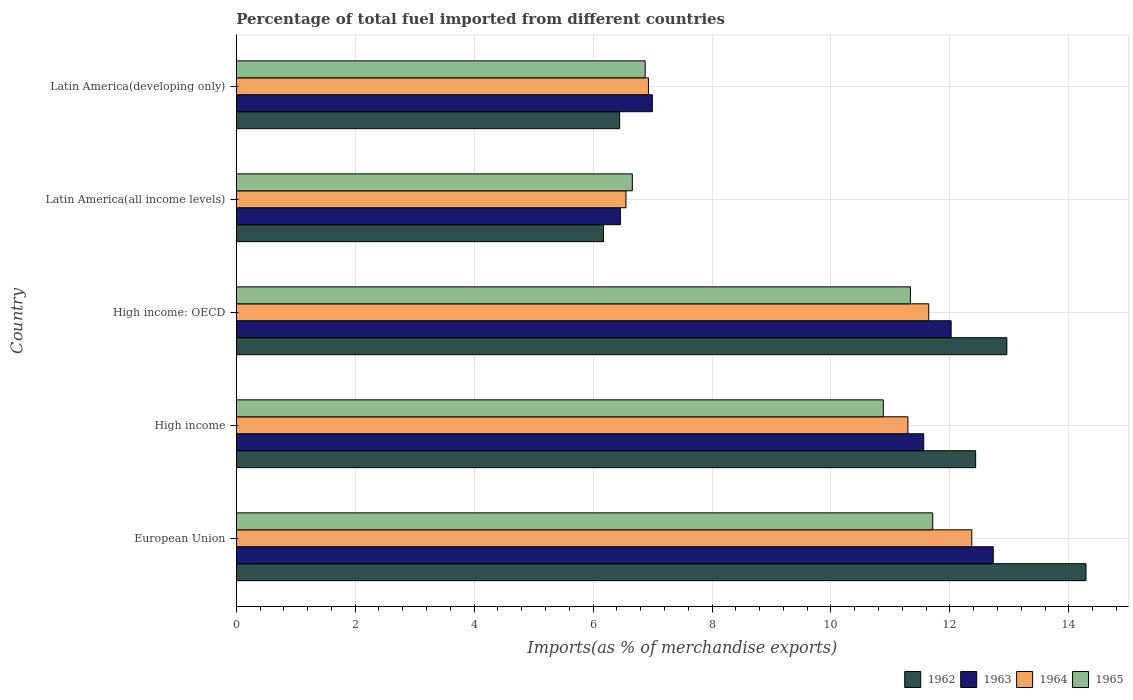How many different coloured bars are there?
Offer a terse response. 4. Are the number of bars on each tick of the Y-axis equal?
Offer a very short reply. Yes. What is the label of the 2nd group of bars from the top?
Give a very brief answer. Latin America(all income levels). What is the percentage of imports to different countries in 1962 in Latin America(developing only)?
Provide a succinct answer. 6.45. Across all countries, what is the maximum percentage of imports to different countries in 1964?
Your answer should be very brief. 12.37. Across all countries, what is the minimum percentage of imports to different countries in 1964?
Your response must be concise. 6.55. In which country was the percentage of imports to different countries in 1965 minimum?
Give a very brief answer. Latin America(all income levels). What is the total percentage of imports to different countries in 1963 in the graph?
Make the answer very short. 49.76. What is the difference between the percentage of imports to different countries in 1964 in European Union and that in Latin America(developing only)?
Provide a succinct answer. 5.44. What is the difference between the percentage of imports to different countries in 1965 in High income and the percentage of imports to different countries in 1963 in European Union?
Offer a very short reply. -1.85. What is the average percentage of imports to different countries in 1964 per country?
Give a very brief answer. 9.76. What is the difference between the percentage of imports to different countries in 1963 and percentage of imports to different countries in 1962 in European Union?
Your response must be concise. -1.56. What is the ratio of the percentage of imports to different countries in 1965 in European Union to that in High income?
Give a very brief answer. 1.08. Is the percentage of imports to different countries in 1962 in High income less than that in High income: OECD?
Provide a short and direct response. Yes. What is the difference between the highest and the second highest percentage of imports to different countries in 1964?
Offer a terse response. 0.72. What is the difference between the highest and the lowest percentage of imports to different countries in 1964?
Provide a succinct answer. 5.81. Is the sum of the percentage of imports to different countries in 1963 in High income: OECD and Latin America(all income levels) greater than the maximum percentage of imports to different countries in 1962 across all countries?
Give a very brief answer. Yes. Is it the case that in every country, the sum of the percentage of imports to different countries in 1964 and percentage of imports to different countries in 1962 is greater than the sum of percentage of imports to different countries in 1965 and percentage of imports to different countries in 1963?
Offer a terse response. No. What does the 4th bar from the top in Latin America(all income levels) represents?
Your answer should be very brief. 1962. What does the 3rd bar from the bottom in Latin America(all income levels) represents?
Give a very brief answer. 1964. How many bars are there?
Provide a succinct answer. 20. Are all the bars in the graph horizontal?
Your answer should be compact. Yes. How many countries are there in the graph?
Make the answer very short. 5. What is the difference between two consecutive major ticks on the X-axis?
Your response must be concise. 2. Does the graph contain grids?
Keep it short and to the point. Yes. How many legend labels are there?
Your answer should be compact. 4. What is the title of the graph?
Your response must be concise. Percentage of total fuel imported from different countries. What is the label or title of the X-axis?
Offer a terse response. Imports(as % of merchandise exports). What is the Imports(as % of merchandise exports) of 1962 in European Union?
Provide a short and direct response. 14.29. What is the Imports(as % of merchandise exports) of 1963 in European Union?
Offer a terse response. 12.73. What is the Imports(as % of merchandise exports) of 1964 in European Union?
Provide a short and direct response. 12.37. What is the Imports(as % of merchandise exports) of 1965 in European Union?
Your answer should be compact. 11.71. What is the Imports(as % of merchandise exports) in 1962 in High income?
Your answer should be very brief. 12.43. What is the Imports(as % of merchandise exports) in 1963 in High income?
Keep it short and to the point. 11.56. What is the Imports(as % of merchandise exports) of 1964 in High income?
Offer a terse response. 11.29. What is the Imports(as % of merchandise exports) of 1965 in High income?
Your answer should be compact. 10.88. What is the Imports(as % of merchandise exports) of 1962 in High income: OECD?
Make the answer very short. 12.96. What is the Imports(as % of merchandise exports) in 1963 in High income: OECD?
Give a very brief answer. 12.02. What is the Imports(as % of merchandise exports) in 1964 in High income: OECD?
Your answer should be very brief. 11.64. What is the Imports(as % of merchandise exports) in 1965 in High income: OECD?
Provide a short and direct response. 11.34. What is the Imports(as % of merchandise exports) in 1962 in Latin America(all income levels)?
Keep it short and to the point. 6.17. What is the Imports(as % of merchandise exports) of 1963 in Latin America(all income levels)?
Ensure brevity in your answer.  6.46. What is the Imports(as % of merchandise exports) in 1964 in Latin America(all income levels)?
Provide a succinct answer. 6.55. What is the Imports(as % of merchandise exports) in 1965 in Latin America(all income levels)?
Make the answer very short. 6.66. What is the Imports(as % of merchandise exports) of 1962 in Latin America(developing only)?
Offer a terse response. 6.45. What is the Imports(as % of merchandise exports) in 1963 in Latin America(developing only)?
Offer a very short reply. 7. What is the Imports(as % of merchandise exports) of 1964 in Latin America(developing only)?
Provide a succinct answer. 6.93. What is the Imports(as % of merchandise exports) in 1965 in Latin America(developing only)?
Your answer should be compact. 6.88. Across all countries, what is the maximum Imports(as % of merchandise exports) of 1962?
Provide a succinct answer. 14.29. Across all countries, what is the maximum Imports(as % of merchandise exports) of 1963?
Provide a short and direct response. 12.73. Across all countries, what is the maximum Imports(as % of merchandise exports) of 1964?
Give a very brief answer. 12.37. Across all countries, what is the maximum Imports(as % of merchandise exports) in 1965?
Offer a terse response. 11.71. Across all countries, what is the minimum Imports(as % of merchandise exports) in 1962?
Provide a succinct answer. 6.17. Across all countries, what is the minimum Imports(as % of merchandise exports) in 1963?
Offer a terse response. 6.46. Across all countries, what is the minimum Imports(as % of merchandise exports) of 1964?
Offer a terse response. 6.55. Across all countries, what is the minimum Imports(as % of merchandise exports) in 1965?
Your response must be concise. 6.66. What is the total Imports(as % of merchandise exports) in 1962 in the graph?
Provide a short and direct response. 52.3. What is the total Imports(as % of merchandise exports) in 1963 in the graph?
Give a very brief answer. 49.76. What is the total Imports(as % of merchandise exports) in 1964 in the graph?
Make the answer very short. 48.79. What is the total Imports(as % of merchandise exports) of 1965 in the graph?
Provide a short and direct response. 47.46. What is the difference between the Imports(as % of merchandise exports) of 1962 in European Union and that in High income?
Your answer should be compact. 1.86. What is the difference between the Imports(as % of merchandise exports) in 1963 in European Union and that in High income?
Your answer should be very brief. 1.17. What is the difference between the Imports(as % of merchandise exports) in 1964 in European Union and that in High income?
Make the answer very short. 1.07. What is the difference between the Imports(as % of merchandise exports) of 1965 in European Union and that in High income?
Your answer should be very brief. 0.83. What is the difference between the Imports(as % of merchandise exports) of 1962 in European Union and that in High income: OECD?
Provide a succinct answer. 1.33. What is the difference between the Imports(as % of merchandise exports) of 1963 in European Union and that in High income: OECD?
Your response must be concise. 0.71. What is the difference between the Imports(as % of merchandise exports) in 1964 in European Union and that in High income: OECD?
Provide a succinct answer. 0.72. What is the difference between the Imports(as % of merchandise exports) in 1965 in European Union and that in High income: OECD?
Offer a terse response. 0.38. What is the difference between the Imports(as % of merchandise exports) of 1962 in European Union and that in Latin America(all income levels)?
Make the answer very short. 8.11. What is the difference between the Imports(as % of merchandise exports) in 1963 in European Union and that in Latin America(all income levels)?
Ensure brevity in your answer.  6.27. What is the difference between the Imports(as % of merchandise exports) of 1964 in European Union and that in Latin America(all income levels)?
Offer a very short reply. 5.82. What is the difference between the Imports(as % of merchandise exports) in 1965 in European Union and that in Latin America(all income levels)?
Ensure brevity in your answer.  5.05. What is the difference between the Imports(as % of merchandise exports) in 1962 in European Union and that in Latin America(developing only)?
Keep it short and to the point. 7.84. What is the difference between the Imports(as % of merchandise exports) of 1963 in European Union and that in Latin America(developing only)?
Provide a short and direct response. 5.73. What is the difference between the Imports(as % of merchandise exports) in 1964 in European Union and that in Latin America(developing only)?
Provide a short and direct response. 5.44. What is the difference between the Imports(as % of merchandise exports) of 1965 in European Union and that in Latin America(developing only)?
Offer a very short reply. 4.84. What is the difference between the Imports(as % of merchandise exports) of 1962 in High income and that in High income: OECD?
Offer a very short reply. -0.52. What is the difference between the Imports(as % of merchandise exports) in 1963 in High income and that in High income: OECD?
Your answer should be compact. -0.46. What is the difference between the Imports(as % of merchandise exports) in 1964 in High income and that in High income: OECD?
Give a very brief answer. -0.35. What is the difference between the Imports(as % of merchandise exports) of 1965 in High income and that in High income: OECD?
Offer a terse response. -0.46. What is the difference between the Imports(as % of merchandise exports) of 1962 in High income and that in Latin America(all income levels)?
Provide a short and direct response. 6.26. What is the difference between the Imports(as % of merchandise exports) in 1963 in High income and that in Latin America(all income levels)?
Your answer should be compact. 5.1. What is the difference between the Imports(as % of merchandise exports) of 1964 in High income and that in Latin America(all income levels)?
Provide a short and direct response. 4.74. What is the difference between the Imports(as % of merchandise exports) in 1965 in High income and that in Latin America(all income levels)?
Your answer should be very brief. 4.22. What is the difference between the Imports(as % of merchandise exports) in 1962 in High income and that in Latin America(developing only)?
Give a very brief answer. 5.99. What is the difference between the Imports(as % of merchandise exports) of 1963 in High income and that in Latin America(developing only)?
Ensure brevity in your answer.  4.56. What is the difference between the Imports(as % of merchandise exports) of 1964 in High income and that in Latin America(developing only)?
Your answer should be very brief. 4.36. What is the difference between the Imports(as % of merchandise exports) of 1965 in High income and that in Latin America(developing only)?
Keep it short and to the point. 4. What is the difference between the Imports(as % of merchandise exports) in 1962 in High income: OECD and that in Latin America(all income levels)?
Make the answer very short. 6.78. What is the difference between the Imports(as % of merchandise exports) in 1963 in High income: OECD and that in Latin America(all income levels)?
Your response must be concise. 5.56. What is the difference between the Imports(as % of merchandise exports) of 1964 in High income: OECD and that in Latin America(all income levels)?
Offer a terse response. 5.09. What is the difference between the Imports(as % of merchandise exports) of 1965 in High income: OECD and that in Latin America(all income levels)?
Your answer should be compact. 4.68. What is the difference between the Imports(as % of merchandise exports) in 1962 in High income: OECD and that in Latin America(developing only)?
Give a very brief answer. 6.51. What is the difference between the Imports(as % of merchandise exports) in 1963 in High income: OECD and that in Latin America(developing only)?
Your answer should be compact. 5.02. What is the difference between the Imports(as % of merchandise exports) of 1964 in High income: OECD and that in Latin America(developing only)?
Give a very brief answer. 4.71. What is the difference between the Imports(as % of merchandise exports) of 1965 in High income: OECD and that in Latin America(developing only)?
Ensure brevity in your answer.  4.46. What is the difference between the Imports(as % of merchandise exports) in 1962 in Latin America(all income levels) and that in Latin America(developing only)?
Offer a very short reply. -0.27. What is the difference between the Imports(as % of merchandise exports) in 1963 in Latin America(all income levels) and that in Latin America(developing only)?
Provide a succinct answer. -0.54. What is the difference between the Imports(as % of merchandise exports) in 1964 in Latin America(all income levels) and that in Latin America(developing only)?
Keep it short and to the point. -0.38. What is the difference between the Imports(as % of merchandise exports) in 1965 in Latin America(all income levels) and that in Latin America(developing only)?
Your answer should be very brief. -0.22. What is the difference between the Imports(as % of merchandise exports) in 1962 in European Union and the Imports(as % of merchandise exports) in 1963 in High income?
Your answer should be compact. 2.73. What is the difference between the Imports(as % of merchandise exports) in 1962 in European Union and the Imports(as % of merchandise exports) in 1964 in High income?
Provide a succinct answer. 2.99. What is the difference between the Imports(as % of merchandise exports) in 1962 in European Union and the Imports(as % of merchandise exports) in 1965 in High income?
Ensure brevity in your answer.  3.41. What is the difference between the Imports(as % of merchandise exports) in 1963 in European Union and the Imports(as % of merchandise exports) in 1964 in High income?
Provide a succinct answer. 1.43. What is the difference between the Imports(as % of merchandise exports) in 1963 in European Union and the Imports(as % of merchandise exports) in 1965 in High income?
Offer a terse response. 1.85. What is the difference between the Imports(as % of merchandise exports) of 1964 in European Union and the Imports(as % of merchandise exports) of 1965 in High income?
Provide a short and direct response. 1.49. What is the difference between the Imports(as % of merchandise exports) of 1962 in European Union and the Imports(as % of merchandise exports) of 1963 in High income: OECD?
Ensure brevity in your answer.  2.27. What is the difference between the Imports(as % of merchandise exports) in 1962 in European Union and the Imports(as % of merchandise exports) in 1964 in High income: OECD?
Provide a short and direct response. 2.64. What is the difference between the Imports(as % of merchandise exports) in 1962 in European Union and the Imports(as % of merchandise exports) in 1965 in High income: OECD?
Keep it short and to the point. 2.95. What is the difference between the Imports(as % of merchandise exports) in 1963 in European Union and the Imports(as % of merchandise exports) in 1964 in High income: OECD?
Offer a very short reply. 1.08. What is the difference between the Imports(as % of merchandise exports) in 1963 in European Union and the Imports(as % of merchandise exports) in 1965 in High income: OECD?
Offer a very short reply. 1.39. What is the difference between the Imports(as % of merchandise exports) of 1964 in European Union and the Imports(as % of merchandise exports) of 1965 in High income: OECD?
Give a very brief answer. 1.03. What is the difference between the Imports(as % of merchandise exports) of 1962 in European Union and the Imports(as % of merchandise exports) of 1963 in Latin America(all income levels)?
Offer a very short reply. 7.83. What is the difference between the Imports(as % of merchandise exports) in 1962 in European Union and the Imports(as % of merchandise exports) in 1964 in Latin America(all income levels)?
Offer a very short reply. 7.74. What is the difference between the Imports(as % of merchandise exports) in 1962 in European Union and the Imports(as % of merchandise exports) in 1965 in Latin America(all income levels)?
Make the answer very short. 7.63. What is the difference between the Imports(as % of merchandise exports) of 1963 in European Union and the Imports(as % of merchandise exports) of 1964 in Latin America(all income levels)?
Ensure brevity in your answer.  6.18. What is the difference between the Imports(as % of merchandise exports) in 1963 in European Union and the Imports(as % of merchandise exports) in 1965 in Latin America(all income levels)?
Offer a terse response. 6.07. What is the difference between the Imports(as % of merchandise exports) in 1964 in European Union and the Imports(as % of merchandise exports) in 1965 in Latin America(all income levels)?
Ensure brevity in your answer.  5.71. What is the difference between the Imports(as % of merchandise exports) of 1962 in European Union and the Imports(as % of merchandise exports) of 1963 in Latin America(developing only)?
Provide a short and direct response. 7.29. What is the difference between the Imports(as % of merchandise exports) of 1962 in European Union and the Imports(as % of merchandise exports) of 1964 in Latin America(developing only)?
Keep it short and to the point. 7.36. What is the difference between the Imports(as % of merchandise exports) in 1962 in European Union and the Imports(as % of merchandise exports) in 1965 in Latin America(developing only)?
Give a very brief answer. 7.41. What is the difference between the Imports(as % of merchandise exports) of 1963 in European Union and the Imports(as % of merchandise exports) of 1964 in Latin America(developing only)?
Your answer should be very brief. 5.8. What is the difference between the Imports(as % of merchandise exports) of 1963 in European Union and the Imports(as % of merchandise exports) of 1965 in Latin America(developing only)?
Ensure brevity in your answer.  5.85. What is the difference between the Imports(as % of merchandise exports) in 1964 in European Union and the Imports(as % of merchandise exports) in 1965 in Latin America(developing only)?
Your answer should be very brief. 5.49. What is the difference between the Imports(as % of merchandise exports) in 1962 in High income and the Imports(as % of merchandise exports) in 1963 in High income: OECD?
Make the answer very short. 0.41. What is the difference between the Imports(as % of merchandise exports) of 1962 in High income and the Imports(as % of merchandise exports) of 1964 in High income: OECD?
Your answer should be compact. 0.79. What is the difference between the Imports(as % of merchandise exports) in 1962 in High income and the Imports(as % of merchandise exports) in 1965 in High income: OECD?
Offer a terse response. 1.1. What is the difference between the Imports(as % of merchandise exports) in 1963 in High income and the Imports(as % of merchandise exports) in 1964 in High income: OECD?
Your response must be concise. -0.09. What is the difference between the Imports(as % of merchandise exports) in 1963 in High income and the Imports(as % of merchandise exports) in 1965 in High income: OECD?
Your answer should be compact. 0.22. What is the difference between the Imports(as % of merchandise exports) of 1964 in High income and the Imports(as % of merchandise exports) of 1965 in High income: OECD?
Ensure brevity in your answer.  -0.04. What is the difference between the Imports(as % of merchandise exports) in 1962 in High income and the Imports(as % of merchandise exports) in 1963 in Latin America(all income levels)?
Give a very brief answer. 5.97. What is the difference between the Imports(as % of merchandise exports) of 1962 in High income and the Imports(as % of merchandise exports) of 1964 in Latin America(all income levels)?
Make the answer very short. 5.88. What is the difference between the Imports(as % of merchandise exports) of 1962 in High income and the Imports(as % of merchandise exports) of 1965 in Latin America(all income levels)?
Your answer should be compact. 5.77. What is the difference between the Imports(as % of merchandise exports) in 1963 in High income and the Imports(as % of merchandise exports) in 1964 in Latin America(all income levels)?
Ensure brevity in your answer.  5.01. What is the difference between the Imports(as % of merchandise exports) in 1963 in High income and the Imports(as % of merchandise exports) in 1965 in Latin America(all income levels)?
Ensure brevity in your answer.  4.9. What is the difference between the Imports(as % of merchandise exports) in 1964 in High income and the Imports(as % of merchandise exports) in 1965 in Latin America(all income levels)?
Offer a very short reply. 4.63. What is the difference between the Imports(as % of merchandise exports) of 1962 in High income and the Imports(as % of merchandise exports) of 1963 in Latin America(developing only)?
Your response must be concise. 5.44. What is the difference between the Imports(as % of merchandise exports) of 1962 in High income and the Imports(as % of merchandise exports) of 1964 in Latin America(developing only)?
Make the answer very short. 5.5. What is the difference between the Imports(as % of merchandise exports) of 1962 in High income and the Imports(as % of merchandise exports) of 1965 in Latin America(developing only)?
Your answer should be very brief. 5.56. What is the difference between the Imports(as % of merchandise exports) in 1963 in High income and the Imports(as % of merchandise exports) in 1964 in Latin America(developing only)?
Your answer should be compact. 4.63. What is the difference between the Imports(as % of merchandise exports) of 1963 in High income and the Imports(as % of merchandise exports) of 1965 in Latin America(developing only)?
Provide a succinct answer. 4.68. What is the difference between the Imports(as % of merchandise exports) in 1964 in High income and the Imports(as % of merchandise exports) in 1965 in Latin America(developing only)?
Keep it short and to the point. 4.42. What is the difference between the Imports(as % of merchandise exports) of 1962 in High income: OECD and the Imports(as % of merchandise exports) of 1963 in Latin America(all income levels)?
Offer a terse response. 6.5. What is the difference between the Imports(as % of merchandise exports) in 1962 in High income: OECD and the Imports(as % of merchandise exports) in 1964 in Latin America(all income levels)?
Offer a very short reply. 6.4. What is the difference between the Imports(as % of merchandise exports) in 1962 in High income: OECD and the Imports(as % of merchandise exports) in 1965 in Latin America(all income levels)?
Your answer should be compact. 6.3. What is the difference between the Imports(as % of merchandise exports) in 1963 in High income: OECD and the Imports(as % of merchandise exports) in 1964 in Latin America(all income levels)?
Give a very brief answer. 5.47. What is the difference between the Imports(as % of merchandise exports) in 1963 in High income: OECD and the Imports(as % of merchandise exports) in 1965 in Latin America(all income levels)?
Your answer should be compact. 5.36. What is the difference between the Imports(as % of merchandise exports) in 1964 in High income: OECD and the Imports(as % of merchandise exports) in 1965 in Latin America(all income levels)?
Keep it short and to the point. 4.98. What is the difference between the Imports(as % of merchandise exports) in 1962 in High income: OECD and the Imports(as % of merchandise exports) in 1963 in Latin America(developing only)?
Give a very brief answer. 5.96. What is the difference between the Imports(as % of merchandise exports) of 1962 in High income: OECD and the Imports(as % of merchandise exports) of 1964 in Latin America(developing only)?
Provide a succinct answer. 6.03. What is the difference between the Imports(as % of merchandise exports) of 1962 in High income: OECD and the Imports(as % of merchandise exports) of 1965 in Latin America(developing only)?
Provide a succinct answer. 6.08. What is the difference between the Imports(as % of merchandise exports) of 1963 in High income: OECD and the Imports(as % of merchandise exports) of 1964 in Latin America(developing only)?
Provide a short and direct response. 5.09. What is the difference between the Imports(as % of merchandise exports) of 1963 in High income: OECD and the Imports(as % of merchandise exports) of 1965 in Latin America(developing only)?
Your answer should be very brief. 5.15. What is the difference between the Imports(as % of merchandise exports) in 1964 in High income: OECD and the Imports(as % of merchandise exports) in 1965 in Latin America(developing only)?
Offer a terse response. 4.77. What is the difference between the Imports(as % of merchandise exports) of 1962 in Latin America(all income levels) and the Imports(as % of merchandise exports) of 1963 in Latin America(developing only)?
Offer a terse response. -0.82. What is the difference between the Imports(as % of merchandise exports) of 1962 in Latin America(all income levels) and the Imports(as % of merchandise exports) of 1964 in Latin America(developing only)?
Ensure brevity in your answer.  -0.76. What is the difference between the Imports(as % of merchandise exports) of 1962 in Latin America(all income levels) and the Imports(as % of merchandise exports) of 1965 in Latin America(developing only)?
Provide a short and direct response. -0.7. What is the difference between the Imports(as % of merchandise exports) in 1963 in Latin America(all income levels) and the Imports(as % of merchandise exports) in 1964 in Latin America(developing only)?
Make the answer very short. -0.47. What is the difference between the Imports(as % of merchandise exports) of 1963 in Latin America(all income levels) and the Imports(as % of merchandise exports) of 1965 in Latin America(developing only)?
Provide a succinct answer. -0.42. What is the difference between the Imports(as % of merchandise exports) in 1964 in Latin America(all income levels) and the Imports(as % of merchandise exports) in 1965 in Latin America(developing only)?
Give a very brief answer. -0.32. What is the average Imports(as % of merchandise exports) in 1962 per country?
Ensure brevity in your answer.  10.46. What is the average Imports(as % of merchandise exports) of 1963 per country?
Your answer should be compact. 9.95. What is the average Imports(as % of merchandise exports) of 1964 per country?
Give a very brief answer. 9.76. What is the average Imports(as % of merchandise exports) in 1965 per country?
Keep it short and to the point. 9.49. What is the difference between the Imports(as % of merchandise exports) of 1962 and Imports(as % of merchandise exports) of 1963 in European Union?
Your answer should be compact. 1.56. What is the difference between the Imports(as % of merchandise exports) of 1962 and Imports(as % of merchandise exports) of 1964 in European Union?
Provide a short and direct response. 1.92. What is the difference between the Imports(as % of merchandise exports) in 1962 and Imports(as % of merchandise exports) in 1965 in European Union?
Your response must be concise. 2.58. What is the difference between the Imports(as % of merchandise exports) in 1963 and Imports(as % of merchandise exports) in 1964 in European Union?
Provide a succinct answer. 0.36. What is the difference between the Imports(as % of merchandise exports) in 1963 and Imports(as % of merchandise exports) in 1965 in European Union?
Provide a short and direct response. 1.02. What is the difference between the Imports(as % of merchandise exports) of 1964 and Imports(as % of merchandise exports) of 1965 in European Union?
Offer a terse response. 0.66. What is the difference between the Imports(as % of merchandise exports) in 1962 and Imports(as % of merchandise exports) in 1963 in High income?
Your response must be concise. 0.87. What is the difference between the Imports(as % of merchandise exports) in 1962 and Imports(as % of merchandise exports) in 1964 in High income?
Provide a succinct answer. 1.14. What is the difference between the Imports(as % of merchandise exports) in 1962 and Imports(as % of merchandise exports) in 1965 in High income?
Keep it short and to the point. 1.55. What is the difference between the Imports(as % of merchandise exports) of 1963 and Imports(as % of merchandise exports) of 1964 in High income?
Give a very brief answer. 0.27. What is the difference between the Imports(as % of merchandise exports) of 1963 and Imports(as % of merchandise exports) of 1965 in High income?
Provide a short and direct response. 0.68. What is the difference between the Imports(as % of merchandise exports) in 1964 and Imports(as % of merchandise exports) in 1965 in High income?
Offer a terse response. 0.41. What is the difference between the Imports(as % of merchandise exports) in 1962 and Imports(as % of merchandise exports) in 1963 in High income: OECD?
Make the answer very short. 0.94. What is the difference between the Imports(as % of merchandise exports) of 1962 and Imports(as % of merchandise exports) of 1964 in High income: OECD?
Make the answer very short. 1.31. What is the difference between the Imports(as % of merchandise exports) of 1962 and Imports(as % of merchandise exports) of 1965 in High income: OECD?
Offer a terse response. 1.62. What is the difference between the Imports(as % of merchandise exports) in 1963 and Imports(as % of merchandise exports) in 1964 in High income: OECD?
Your answer should be very brief. 0.38. What is the difference between the Imports(as % of merchandise exports) of 1963 and Imports(as % of merchandise exports) of 1965 in High income: OECD?
Keep it short and to the point. 0.69. What is the difference between the Imports(as % of merchandise exports) in 1964 and Imports(as % of merchandise exports) in 1965 in High income: OECD?
Ensure brevity in your answer.  0.31. What is the difference between the Imports(as % of merchandise exports) of 1962 and Imports(as % of merchandise exports) of 1963 in Latin America(all income levels)?
Offer a very short reply. -0.28. What is the difference between the Imports(as % of merchandise exports) in 1962 and Imports(as % of merchandise exports) in 1964 in Latin America(all income levels)?
Offer a very short reply. -0.38. What is the difference between the Imports(as % of merchandise exports) in 1962 and Imports(as % of merchandise exports) in 1965 in Latin America(all income levels)?
Give a very brief answer. -0.48. What is the difference between the Imports(as % of merchandise exports) in 1963 and Imports(as % of merchandise exports) in 1964 in Latin America(all income levels)?
Provide a succinct answer. -0.09. What is the difference between the Imports(as % of merchandise exports) of 1963 and Imports(as % of merchandise exports) of 1965 in Latin America(all income levels)?
Your answer should be compact. -0.2. What is the difference between the Imports(as % of merchandise exports) of 1964 and Imports(as % of merchandise exports) of 1965 in Latin America(all income levels)?
Ensure brevity in your answer.  -0.11. What is the difference between the Imports(as % of merchandise exports) in 1962 and Imports(as % of merchandise exports) in 1963 in Latin America(developing only)?
Your response must be concise. -0.55. What is the difference between the Imports(as % of merchandise exports) of 1962 and Imports(as % of merchandise exports) of 1964 in Latin America(developing only)?
Ensure brevity in your answer.  -0.48. What is the difference between the Imports(as % of merchandise exports) in 1962 and Imports(as % of merchandise exports) in 1965 in Latin America(developing only)?
Your answer should be compact. -0.43. What is the difference between the Imports(as % of merchandise exports) of 1963 and Imports(as % of merchandise exports) of 1964 in Latin America(developing only)?
Keep it short and to the point. 0.07. What is the difference between the Imports(as % of merchandise exports) of 1963 and Imports(as % of merchandise exports) of 1965 in Latin America(developing only)?
Ensure brevity in your answer.  0.12. What is the difference between the Imports(as % of merchandise exports) of 1964 and Imports(as % of merchandise exports) of 1965 in Latin America(developing only)?
Give a very brief answer. 0.06. What is the ratio of the Imports(as % of merchandise exports) of 1962 in European Union to that in High income?
Your answer should be compact. 1.15. What is the ratio of the Imports(as % of merchandise exports) in 1963 in European Union to that in High income?
Ensure brevity in your answer.  1.1. What is the ratio of the Imports(as % of merchandise exports) in 1964 in European Union to that in High income?
Provide a succinct answer. 1.1. What is the ratio of the Imports(as % of merchandise exports) of 1965 in European Union to that in High income?
Give a very brief answer. 1.08. What is the ratio of the Imports(as % of merchandise exports) of 1962 in European Union to that in High income: OECD?
Provide a succinct answer. 1.1. What is the ratio of the Imports(as % of merchandise exports) in 1963 in European Union to that in High income: OECD?
Offer a very short reply. 1.06. What is the ratio of the Imports(as % of merchandise exports) in 1964 in European Union to that in High income: OECD?
Offer a very short reply. 1.06. What is the ratio of the Imports(as % of merchandise exports) of 1965 in European Union to that in High income: OECD?
Keep it short and to the point. 1.03. What is the ratio of the Imports(as % of merchandise exports) of 1962 in European Union to that in Latin America(all income levels)?
Your answer should be compact. 2.31. What is the ratio of the Imports(as % of merchandise exports) in 1963 in European Union to that in Latin America(all income levels)?
Provide a succinct answer. 1.97. What is the ratio of the Imports(as % of merchandise exports) in 1964 in European Union to that in Latin America(all income levels)?
Keep it short and to the point. 1.89. What is the ratio of the Imports(as % of merchandise exports) in 1965 in European Union to that in Latin America(all income levels)?
Provide a succinct answer. 1.76. What is the ratio of the Imports(as % of merchandise exports) of 1962 in European Union to that in Latin America(developing only)?
Make the answer very short. 2.22. What is the ratio of the Imports(as % of merchandise exports) of 1963 in European Union to that in Latin America(developing only)?
Your response must be concise. 1.82. What is the ratio of the Imports(as % of merchandise exports) of 1964 in European Union to that in Latin America(developing only)?
Your answer should be very brief. 1.78. What is the ratio of the Imports(as % of merchandise exports) of 1965 in European Union to that in Latin America(developing only)?
Keep it short and to the point. 1.7. What is the ratio of the Imports(as % of merchandise exports) in 1962 in High income to that in High income: OECD?
Offer a very short reply. 0.96. What is the ratio of the Imports(as % of merchandise exports) of 1963 in High income to that in High income: OECD?
Ensure brevity in your answer.  0.96. What is the ratio of the Imports(as % of merchandise exports) in 1964 in High income to that in High income: OECD?
Offer a very short reply. 0.97. What is the ratio of the Imports(as % of merchandise exports) in 1965 in High income to that in High income: OECD?
Offer a very short reply. 0.96. What is the ratio of the Imports(as % of merchandise exports) of 1962 in High income to that in Latin America(all income levels)?
Provide a short and direct response. 2.01. What is the ratio of the Imports(as % of merchandise exports) in 1963 in High income to that in Latin America(all income levels)?
Your answer should be very brief. 1.79. What is the ratio of the Imports(as % of merchandise exports) of 1964 in High income to that in Latin America(all income levels)?
Offer a terse response. 1.72. What is the ratio of the Imports(as % of merchandise exports) in 1965 in High income to that in Latin America(all income levels)?
Your answer should be very brief. 1.63. What is the ratio of the Imports(as % of merchandise exports) of 1962 in High income to that in Latin America(developing only)?
Offer a very short reply. 1.93. What is the ratio of the Imports(as % of merchandise exports) of 1963 in High income to that in Latin America(developing only)?
Ensure brevity in your answer.  1.65. What is the ratio of the Imports(as % of merchandise exports) in 1964 in High income to that in Latin America(developing only)?
Your answer should be very brief. 1.63. What is the ratio of the Imports(as % of merchandise exports) of 1965 in High income to that in Latin America(developing only)?
Your response must be concise. 1.58. What is the ratio of the Imports(as % of merchandise exports) in 1962 in High income: OECD to that in Latin America(all income levels)?
Your answer should be very brief. 2.1. What is the ratio of the Imports(as % of merchandise exports) of 1963 in High income: OECD to that in Latin America(all income levels)?
Your answer should be compact. 1.86. What is the ratio of the Imports(as % of merchandise exports) of 1964 in High income: OECD to that in Latin America(all income levels)?
Your response must be concise. 1.78. What is the ratio of the Imports(as % of merchandise exports) in 1965 in High income: OECD to that in Latin America(all income levels)?
Your response must be concise. 1.7. What is the ratio of the Imports(as % of merchandise exports) in 1962 in High income: OECD to that in Latin America(developing only)?
Provide a succinct answer. 2.01. What is the ratio of the Imports(as % of merchandise exports) in 1963 in High income: OECD to that in Latin America(developing only)?
Ensure brevity in your answer.  1.72. What is the ratio of the Imports(as % of merchandise exports) of 1964 in High income: OECD to that in Latin America(developing only)?
Make the answer very short. 1.68. What is the ratio of the Imports(as % of merchandise exports) of 1965 in High income: OECD to that in Latin America(developing only)?
Your answer should be compact. 1.65. What is the ratio of the Imports(as % of merchandise exports) of 1962 in Latin America(all income levels) to that in Latin America(developing only)?
Ensure brevity in your answer.  0.96. What is the ratio of the Imports(as % of merchandise exports) in 1963 in Latin America(all income levels) to that in Latin America(developing only)?
Give a very brief answer. 0.92. What is the ratio of the Imports(as % of merchandise exports) in 1964 in Latin America(all income levels) to that in Latin America(developing only)?
Make the answer very short. 0.95. What is the ratio of the Imports(as % of merchandise exports) of 1965 in Latin America(all income levels) to that in Latin America(developing only)?
Make the answer very short. 0.97. What is the difference between the highest and the second highest Imports(as % of merchandise exports) in 1962?
Make the answer very short. 1.33. What is the difference between the highest and the second highest Imports(as % of merchandise exports) in 1963?
Your response must be concise. 0.71. What is the difference between the highest and the second highest Imports(as % of merchandise exports) in 1964?
Give a very brief answer. 0.72. What is the difference between the highest and the second highest Imports(as % of merchandise exports) of 1965?
Keep it short and to the point. 0.38. What is the difference between the highest and the lowest Imports(as % of merchandise exports) in 1962?
Provide a succinct answer. 8.11. What is the difference between the highest and the lowest Imports(as % of merchandise exports) of 1963?
Your answer should be compact. 6.27. What is the difference between the highest and the lowest Imports(as % of merchandise exports) in 1964?
Provide a short and direct response. 5.82. What is the difference between the highest and the lowest Imports(as % of merchandise exports) of 1965?
Keep it short and to the point. 5.05. 